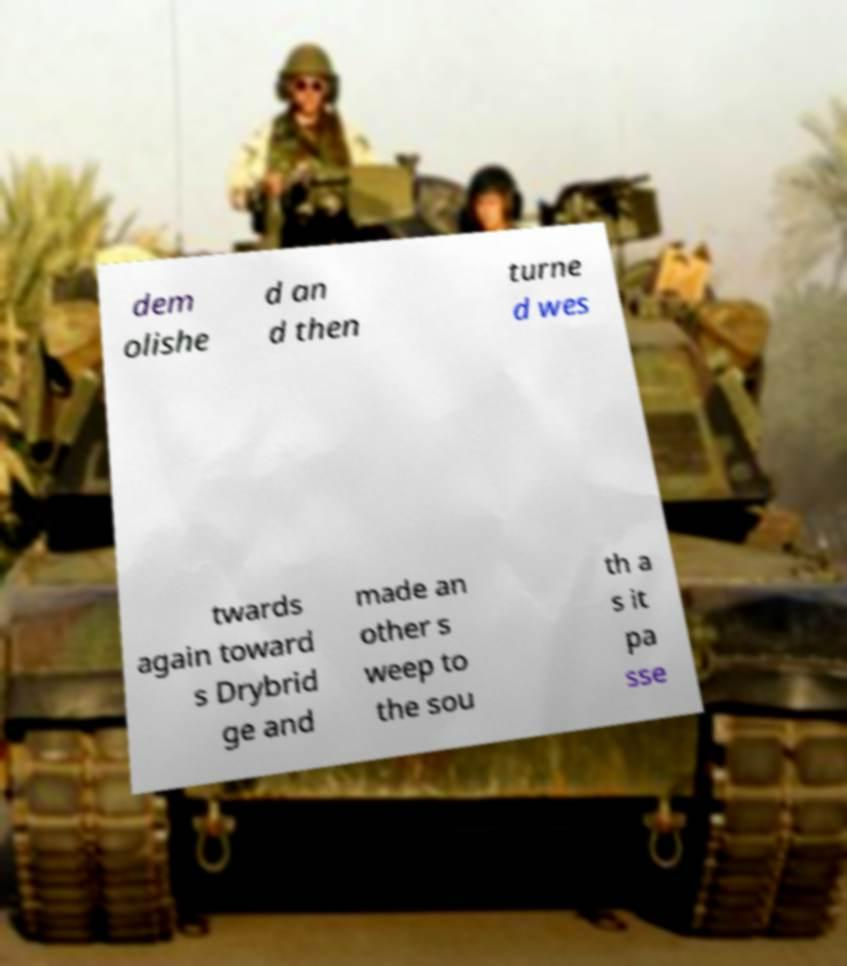Can you read and provide the text displayed in the image?This photo seems to have some interesting text. Can you extract and type it out for me? dem olishe d an d then turne d wes twards again toward s Drybrid ge and made an other s weep to the sou th a s it pa sse 